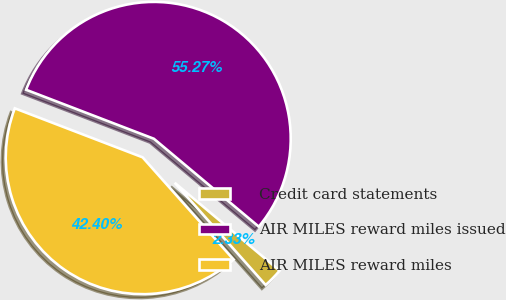<chart> <loc_0><loc_0><loc_500><loc_500><pie_chart><fcel>Credit card statements<fcel>AIR MILES reward miles issued<fcel>AIR MILES reward miles<nl><fcel>2.33%<fcel>55.27%<fcel>42.4%<nl></chart> 